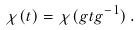<formula> <loc_0><loc_0><loc_500><loc_500>\chi ( t ) = \chi ( g t g ^ { - 1 } ) \, .</formula> 